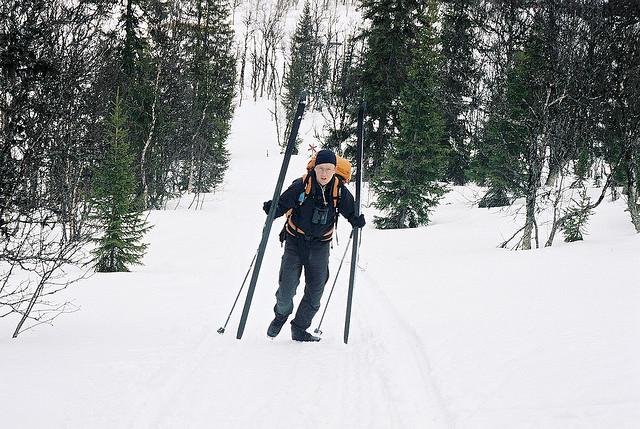Is he in a forest?
Answer briefly. Yes. What is on the person's back?
Short answer required. Backpack. Is he holding his skis?
Concise answer only. Yes. 